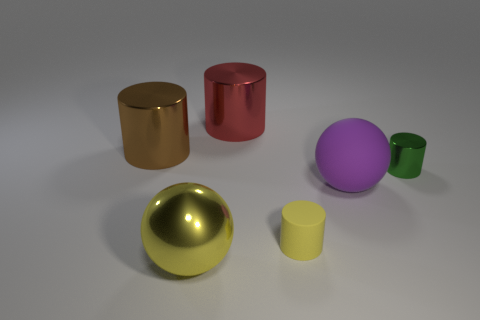Subtract all rubber cylinders. How many cylinders are left? 3 Add 2 big blue metal balls. How many objects exist? 8 Subtract all spheres. How many objects are left? 4 Subtract all purple spheres. How many spheres are left? 1 Add 3 big brown objects. How many big brown objects exist? 4 Subtract 0 gray balls. How many objects are left? 6 Subtract 2 spheres. How many spheres are left? 0 Subtract all yellow cylinders. Subtract all green cubes. How many cylinders are left? 3 Subtract all cyan cylinders. How many yellow spheres are left? 1 Subtract all big gray metallic blocks. Subtract all brown shiny cylinders. How many objects are left? 5 